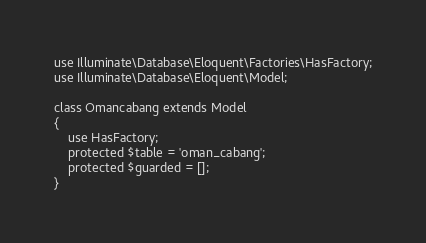<code> <loc_0><loc_0><loc_500><loc_500><_PHP_>use Illuminate\Database\Eloquent\Factories\HasFactory;
use Illuminate\Database\Eloquent\Model;

class Omancabang extends Model
{
    use HasFactory;
    protected $table = 'oman_cabang';
    protected $guarded = [];
}
</code> 